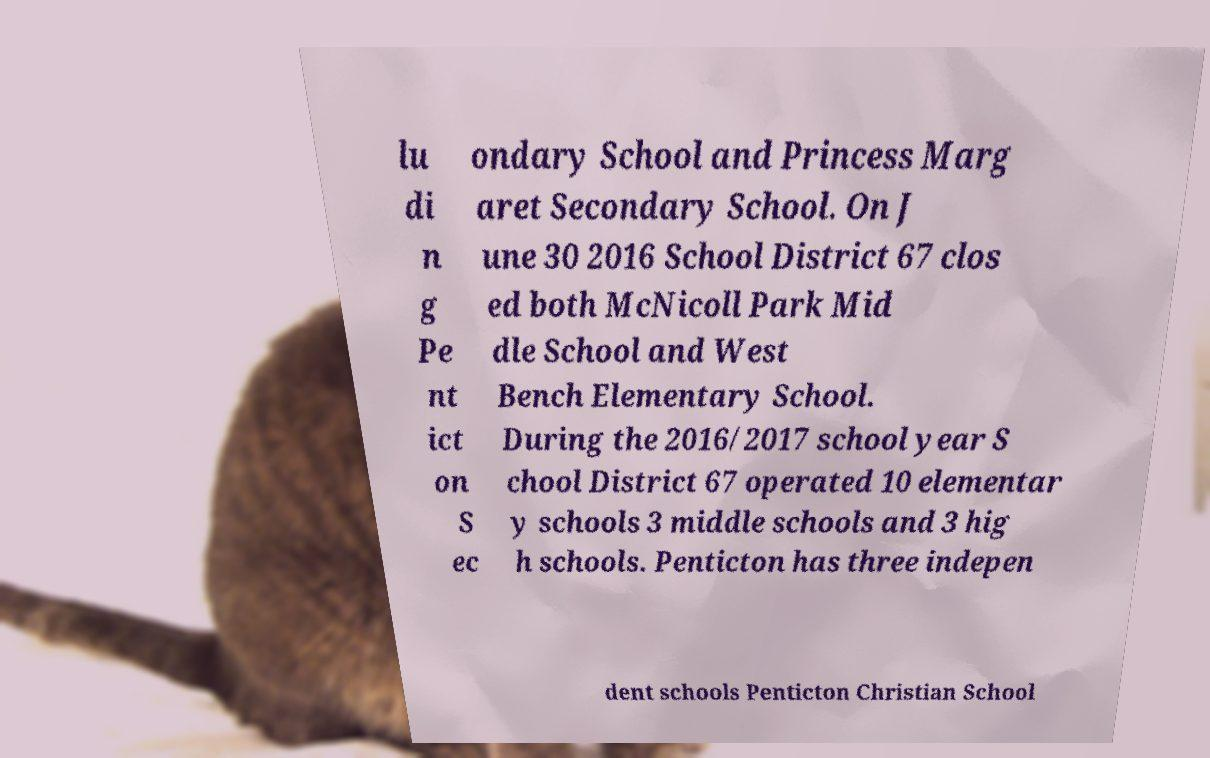There's text embedded in this image that I need extracted. Can you transcribe it verbatim? lu di n g Pe nt ict on S ec ondary School and Princess Marg aret Secondary School. On J une 30 2016 School District 67 clos ed both McNicoll Park Mid dle School and West Bench Elementary School. During the 2016/2017 school year S chool District 67 operated 10 elementar y schools 3 middle schools and 3 hig h schools. Penticton has three indepen dent schools Penticton Christian School 